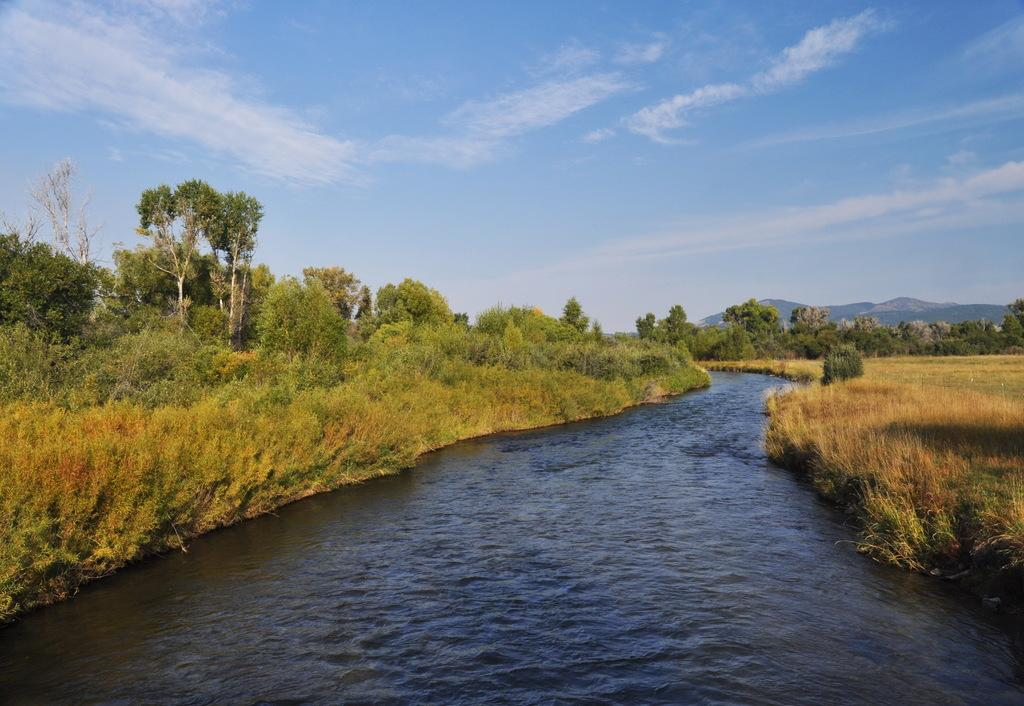What is the main feature in the center of the image? There is a canal in the center of the image. What type of vegetation can be seen in the image? There is grass visible in the image. What can be seen in the background of the image? There are trees, hills, and the sky visible in the background of the image. What type of apparel is the canal wearing in the image? The canal is not a living being and therefore cannot wear apparel. 